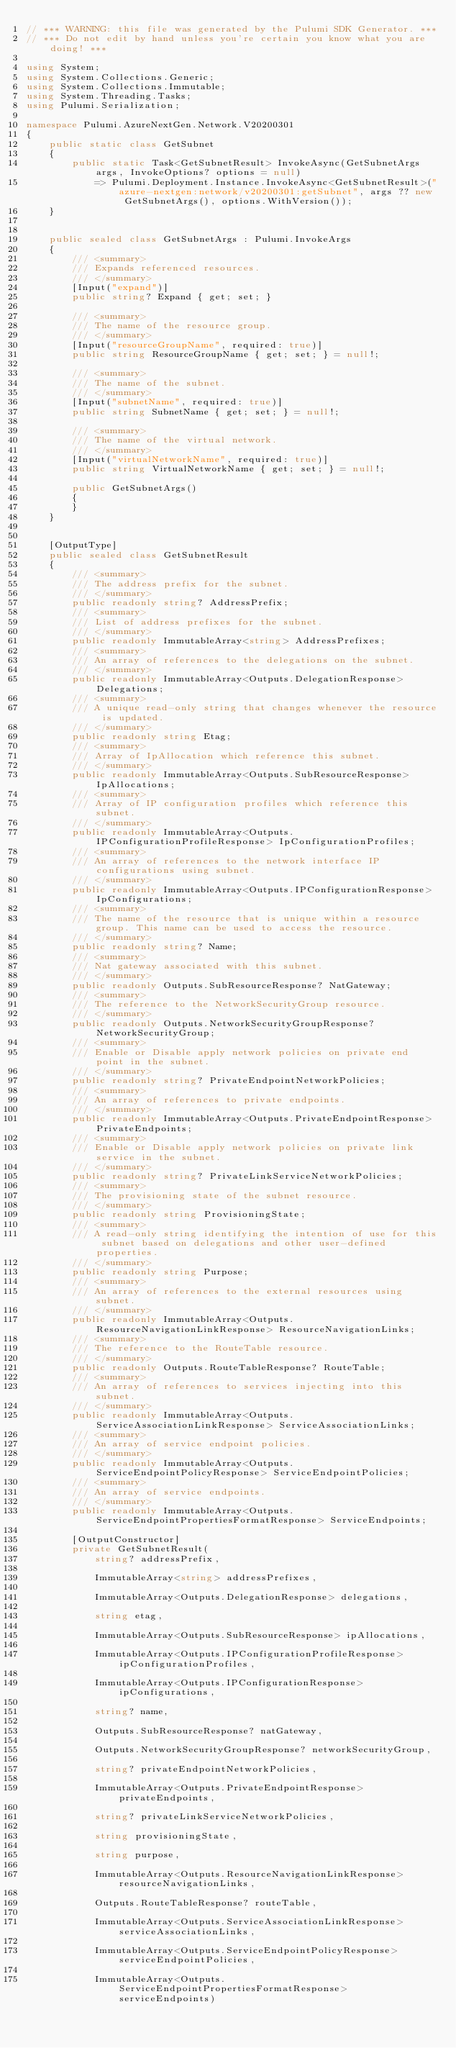Convert code to text. <code><loc_0><loc_0><loc_500><loc_500><_C#_>// *** WARNING: this file was generated by the Pulumi SDK Generator. ***
// *** Do not edit by hand unless you're certain you know what you are doing! ***

using System;
using System.Collections.Generic;
using System.Collections.Immutable;
using System.Threading.Tasks;
using Pulumi.Serialization;

namespace Pulumi.AzureNextGen.Network.V20200301
{
    public static class GetSubnet
    {
        public static Task<GetSubnetResult> InvokeAsync(GetSubnetArgs args, InvokeOptions? options = null)
            => Pulumi.Deployment.Instance.InvokeAsync<GetSubnetResult>("azure-nextgen:network/v20200301:getSubnet", args ?? new GetSubnetArgs(), options.WithVersion());
    }


    public sealed class GetSubnetArgs : Pulumi.InvokeArgs
    {
        /// <summary>
        /// Expands referenced resources.
        /// </summary>
        [Input("expand")]
        public string? Expand { get; set; }

        /// <summary>
        /// The name of the resource group.
        /// </summary>
        [Input("resourceGroupName", required: true)]
        public string ResourceGroupName { get; set; } = null!;

        /// <summary>
        /// The name of the subnet.
        /// </summary>
        [Input("subnetName", required: true)]
        public string SubnetName { get; set; } = null!;

        /// <summary>
        /// The name of the virtual network.
        /// </summary>
        [Input("virtualNetworkName", required: true)]
        public string VirtualNetworkName { get; set; } = null!;

        public GetSubnetArgs()
        {
        }
    }


    [OutputType]
    public sealed class GetSubnetResult
    {
        /// <summary>
        /// The address prefix for the subnet.
        /// </summary>
        public readonly string? AddressPrefix;
        /// <summary>
        /// List of address prefixes for the subnet.
        /// </summary>
        public readonly ImmutableArray<string> AddressPrefixes;
        /// <summary>
        /// An array of references to the delegations on the subnet.
        /// </summary>
        public readonly ImmutableArray<Outputs.DelegationResponse> Delegations;
        /// <summary>
        /// A unique read-only string that changes whenever the resource is updated.
        /// </summary>
        public readonly string Etag;
        /// <summary>
        /// Array of IpAllocation which reference this subnet.
        /// </summary>
        public readonly ImmutableArray<Outputs.SubResourceResponse> IpAllocations;
        /// <summary>
        /// Array of IP configuration profiles which reference this subnet.
        /// </summary>
        public readonly ImmutableArray<Outputs.IPConfigurationProfileResponse> IpConfigurationProfiles;
        /// <summary>
        /// An array of references to the network interface IP configurations using subnet.
        /// </summary>
        public readonly ImmutableArray<Outputs.IPConfigurationResponse> IpConfigurations;
        /// <summary>
        /// The name of the resource that is unique within a resource group. This name can be used to access the resource.
        /// </summary>
        public readonly string? Name;
        /// <summary>
        /// Nat gateway associated with this subnet.
        /// </summary>
        public readonly Outputs.SubResourceResponse? NatGateway;
        /// <summary>
        /// The reference to the NetworkSecurityGroup resource.
        /// </summary>
        public readonly Outputs.NetworkSecurityGroupResponse? NetworkSecurityGroup;
        /// <summary>
        /// Enable or Disable apply network policies on private end point in the subnet.
        /// </summary>
        public readonly string? PrivateEndpointNetworkPolicies;
        /// <summary>
        /// An array of references to private endpoints.
        /// </summary>
        public readonly ImmutableArray<Outputs.PrivateEndpointResponse> PrivateEndpoints;
        /// <summary>
        /// Enable or Disable apply network policies on private link service in the subnet.
        /// </summary>
        public readonly string? PrivateLinkServiceNetworkPolicies;
        /// <summary>
        /// The provisioning state of the subnet resource.
        /// </summary>
        public readonly string ProvisioningState;
        /// <summary>
        /// A read-only string identifying the intention of use for this subnet based on delegations and other user-defined properties.
        /// </summary>
        public readonly string Purpose;
        /// <summary>
        /// An array of references to the external resources using subnet.
        /// </summary>
        public readonly ImmutableArray<Outputs.ResourceNavigationLinkResponse> ResourceNavigationLinks;
        /// <summary>
        /// The reference to the RouteTable resource.
        /// </summary>
        public readonly Outputs.RouteTableResponse? RouteTable;
        /// <summary>
        /// An array of references to services injecting into this subnet.
        /// </summary>
        public readonly ImmutableArray<Outputs.ServiceAssociationLinkResponse> ServiceAssociationLinks;
        /// <summary>
        /// An array of service endpoint policies.
        /// </summary>
        public readonly ImmutableArray<Outputs.ServiceEndpointPolicyResponse> ServiceEndpointPolicies;
        /// <summary>
        /// An array of service endpoints.
        /// </summary>
        public readonly ImmutableArray<Outputs.ServiceEndpointPropertiesFormatResponse> ServiceEndpoints;

        [OutputConstructor]
        private GetSubnetResult(
            string? addressPrefix,

            ImmutableArray<string> addressPrefixes,

            ImmutableArray<Outputs.DelegationResponse> delegations,

            string etag,

            ImmutableArray<Outputs.SubResourceResponse> ipAllocations,

            ImmutableArray<Outputs.IPConfigurationProfileResponse> ipConfigurationProfiles,

            ImmutableArray<Outputs.IPConfigurationResponse> ipConfigurations,

            string? name,

            Outputs.SubResourceResponse? natGateway,

            Outputs.NetworkSecurityGroupResponse? networkSecurityGroup,

            string? privateEndpointNetworkPolicies,

            ImmutableArray<Outputs.PrivateEndpointResponse> privateEndpoints,

            string? privateLinkServiceNetworkPolicies,

            string provisioningState,

            string purpose,

            ImmutableArray<Outputs.ResourceNavigationLinkResponse> resourceNavigationLinks,

            Outputs.RouteTableResponse? routeTable,

            ImmutableArray<Outputs.ServiceAssociationLinkResponse> serviceAssociationLinks,

            ImmutableArray<Outputs.ServiceEndpointPolicyResponse> serviceEndpointPolicies,

            ImmutableArray<Outputs.ServiceEndpointPropertiesFormatResponse> serviceEndpoints)</code> 